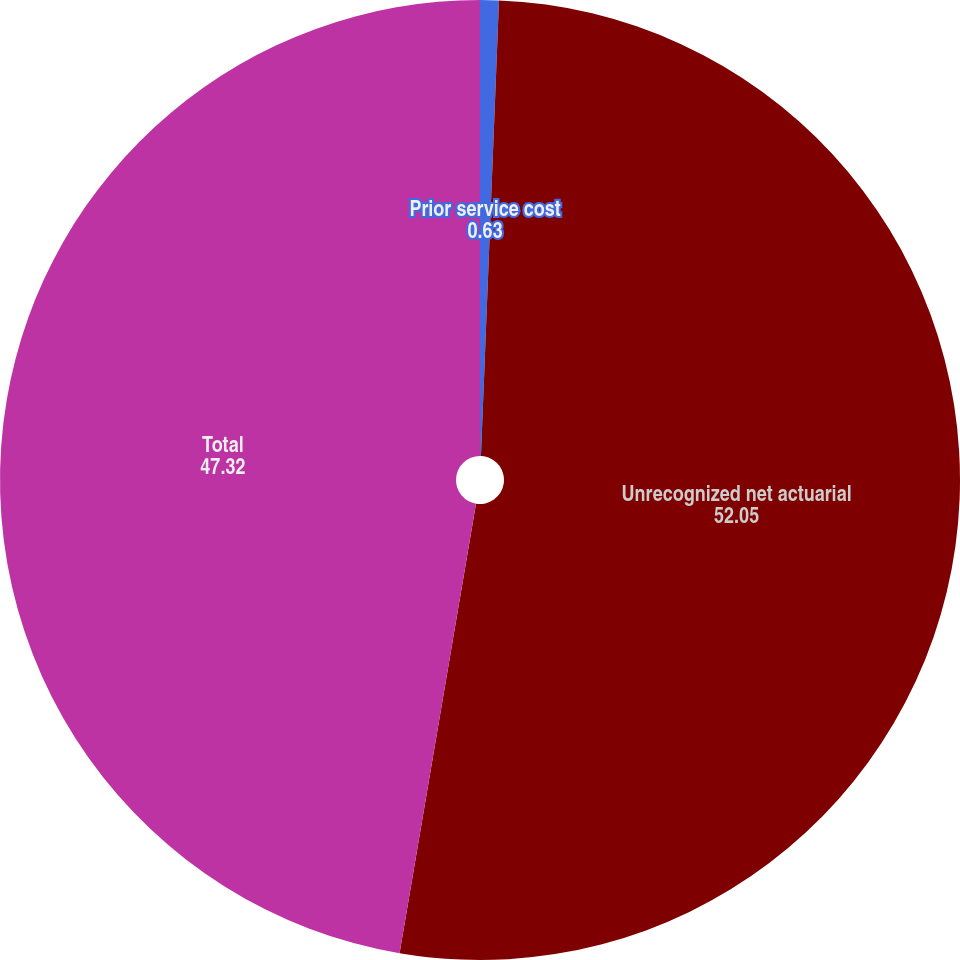<chart> <loc_0><loc_0><loc_500><loc_500><pie_chart><fcel>Prior service cost<fcel>Unrecognized net actuarial<fcel>Total<nl><fcel>0.63%<fcel>52.05%<fcel>47.32%<nl></chart> 